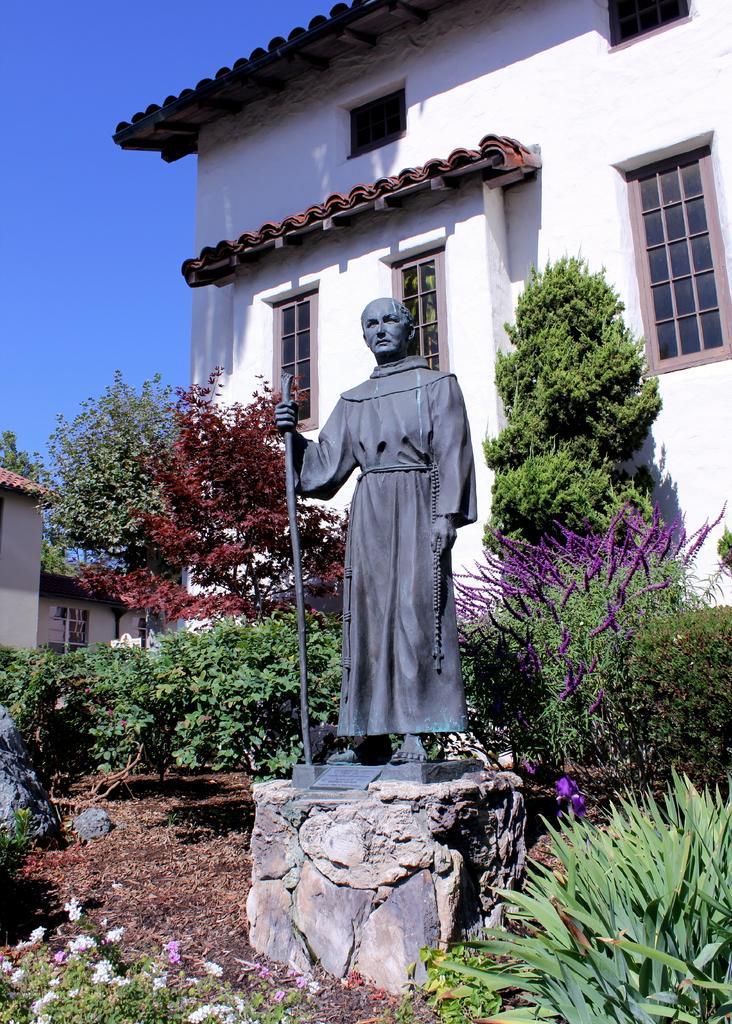In one or two sentences, can you explain what this image depicts? In this image I can see a building , in front of the building I can see trees and sculpture and flowers and on the left side I can see the sky and buildings and I can see windows on the building. 